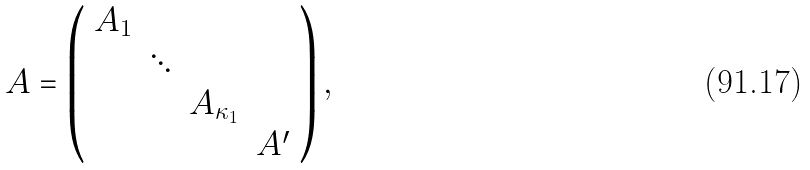Convert formula to latex. <formula><loc_0><loc_0><loc_500><loc_500>A = \left ( \begin{array} { r r r r } A _ { 1 } & & & \\ & \ddots & & \\ & & A _ { \kappa _ { 1 } } & \\ & & & A ^ { \prime } \end{array} \right ) ,</formula> 